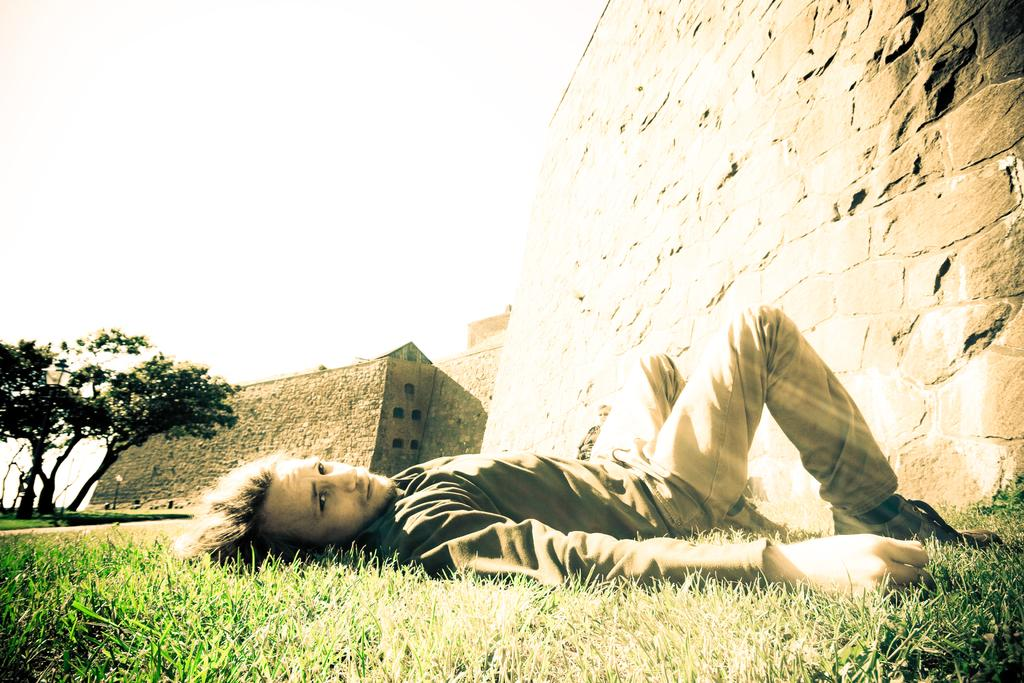What type of surface is on the ground in the image? There is grass on the ground in the image. What is the man in the image doing? The man is laying on the ground in the image. What can be seen in the background of the image? There are walls and trees visible in the background of the image. Can you see a tramp or goat in the image? No, there is no tramp or goat present in the image. What type of plastic object is visible in the image? There is no plastic object visible in the image. 